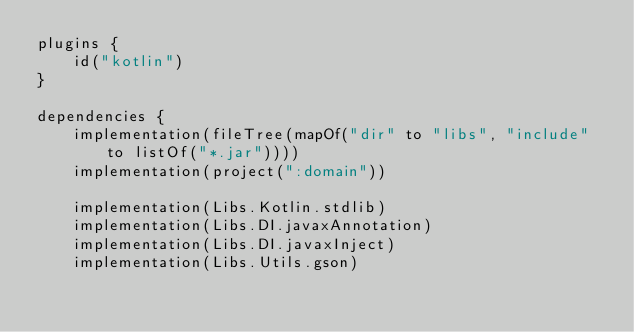Convert code to text. <code><loc_0><loc_0><loc_500><loc_500><_Kotlin_>plugins {
    id("kotlin")
}

dependencies {
    implementation(fileTree(mapOf("dir" to "libs", "include" to listOf("*.jar"))))
    implementation(project(":domain"))

    implementation(Libs.Kotlin.stdlib)
    implementation(Libs.DI.javaxAnnotation)
    implementation(Libs.DI.javaxInject)
    implementation(Libs.Utils.gson)
</code> 